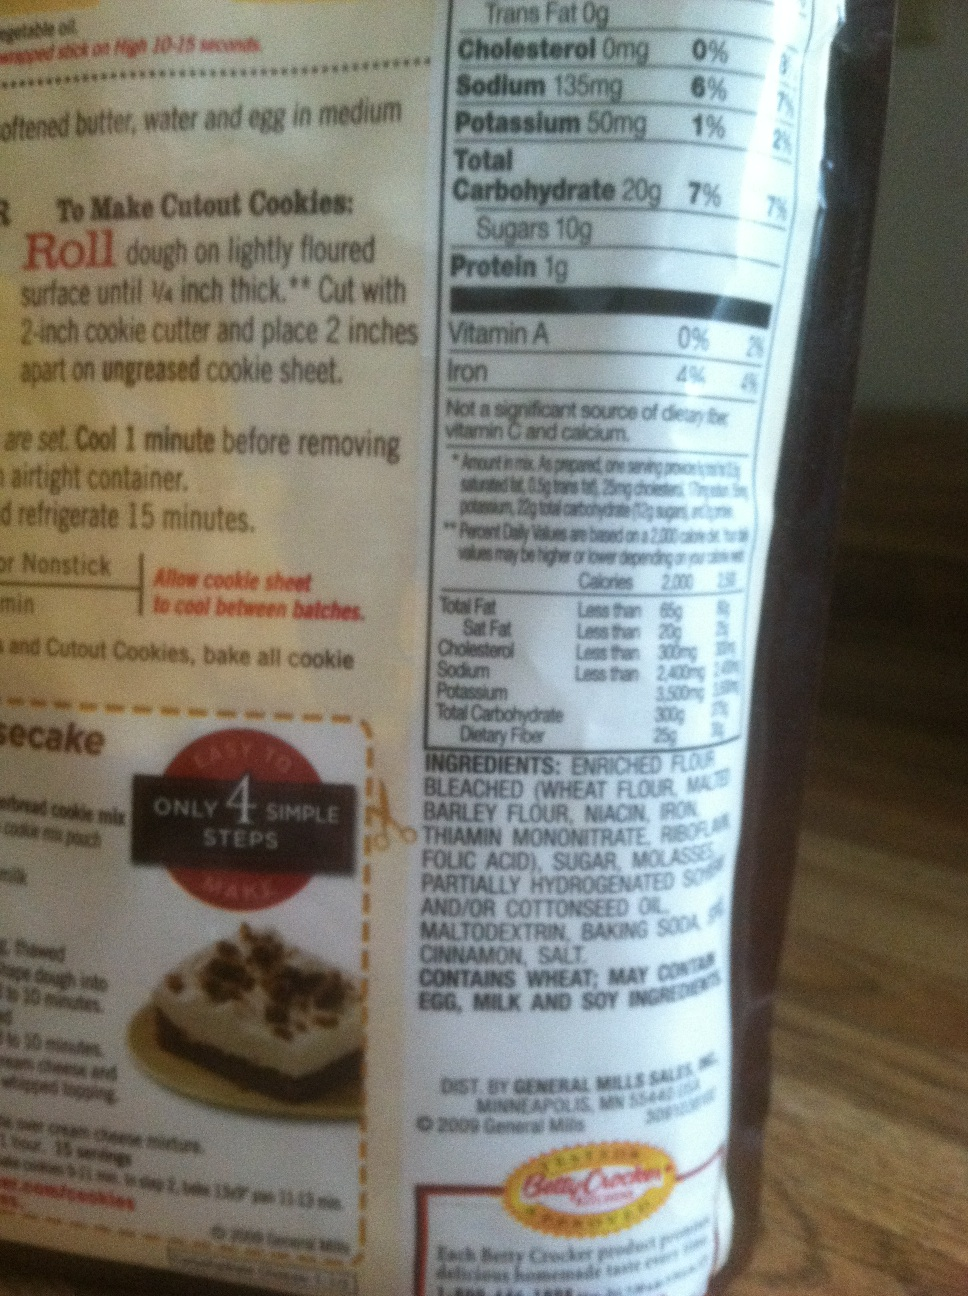Can you describe the nutritional information on this bag? The nutritional information indicates that a serving size is 20g, contributing 2% of the daily recommended amount of iron and 7% of the total carbohydrate intake. It contains no trans fat or cholesterol, and the sodium content is 135mg, which is 6% of the daily value. 